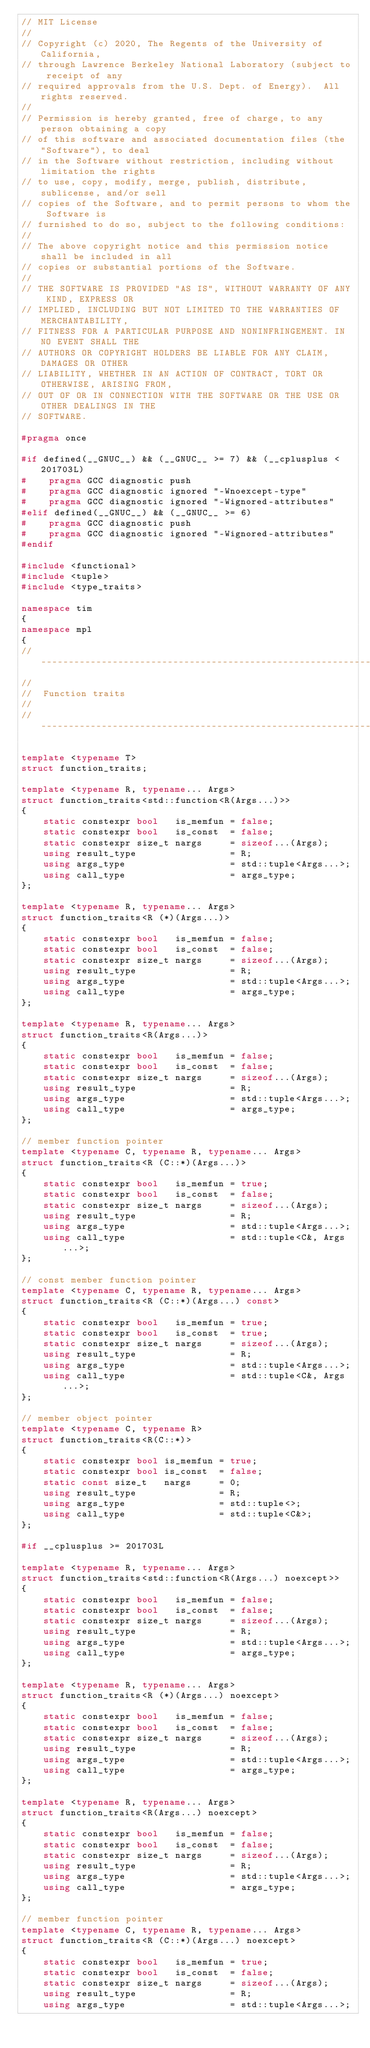<code> <loc_0><loc_0><loc_500><loc_500><_C++_>// MIT License
//
// Copyright (c) 2020, The Regents of the University of California,
// through Lawrence Berkeley National Laboratory (subject to receipt of any
// required approvals from the U.S. Dept. of Energy).  All rights reserved.
//
// Permission is hereby granted, free of charge, to any person obtaining a copy
// of this software and associated documentation files (the "Software"), to deal
// in the Software without restriction, including without limitation the rights
// to use, copy, modify, merge, publish, distribute, sublicense, and/or sell
// copies of the Software, and to permit persons to whom the Software is
// furnished to do so, subject to the following conditions:
//
// The above copyright notice and this permission notice shall be included in all
// copies or substantial portions of the Software.
//
// THE SOFTWARE IS PROVIDED "AS IS", WITHOUT WARRANTY OF ANY KIND, EXPRESS OR
// IMPLIED, INCLUDING BUT NOT LIMITED TO THE WARRANTIES OF MERCHANTABILITY,
// FITNESS FOR A PARTICULAR PURPOSE AND NONINFRINGEMENT. IN NO EVENT SHALL THE
// AUTHORS OR COPYRIGHT HOLDERS BE LIABLE FOR ANY CLAIM, DAMAGES OR OTHER
// LIABILITY, WHETHER IN AN ACTION OF CONTRACT, TORT OR OTHERWISE, ARISING FROM,
// OUT OF OR IN CONNECTION WITH THE SOFTWARE OR THE USE OR OTHER DEALINGS IN THE
// SOFTWARE.

#pragma once

#if defined(__GNUC__) && (__GNUC__ >= 7) && (__cplusplus < 201703L)
#    pragma GCC diagnostic push
#    pragma GCC diagnostic ignored "-Wnoexcept-type"
#    pragma GCC diagnostic ignored "-Wignored-attributes"
#elif defined(__GNUC__) && (__GNUC__ >= 6)
#    pragma GCC diagnostic push
#    pragma GCC diagnostic ignored "-Wignored-attributes"
#endif

#include <functional>
#include <tuple>
#include <type_traits>

namespace tim
{
namespace mpl
{
//--------------------------------------------------------------------------------------//
//
//  Function traits
//
//--------------------------------------------------------------------------------------//

template <typename T>
struct function_traits;

template <typename R, typename... Args>
struct function_traits<std::function<R(Args...)>>
{
    static constexpr bool   is_memfun = false;
    static constexpr bool   is_const  = false;
    static constexpr size_t nargs     = sizeof...(Args);
    using result_type                 = R;
    using args_type                   = std::tuple<Args...>;
    using call_type                   = args_type;
};

template <typename R, typename... Args>
struct function_traits<R (*)(Args...)>
{
    static constexpr bool   is_memfun = false;
    static constexpr bool   is_const  = false;
    static constexpr size_t nargs     = sizeof...(Args);
    using result_type                 = R;
    using args_type                   = std::tuple<Args...>;
    using call_type                   = args_type;
};

template <typename R, typename... Args>
struct function_traits<R(Args...)>
{
    static constexpr bool   is_memfun = false;
    static constexpr bool   is_const  = false;
    static constexpr size_t nargs     = sizeof...(Args);
    using result_type                 = R;
    using args_type                   = std::tuple<Args...>;
    using call_type                   = args_type;
};

// member function pointer
template <typename C, typename R, typename... Args>
struct function_traits<R (C::*)(Args...)>
{
    static constexpr bool   is_memfun = true;
    static constexpr bool   is_const  = false;
    static constexpr size_t nargs     = sizeof...(Args);
    using result_type                 = R;
    using args_type                   = std::tuple<Args...>;
    using call_type                   = std::tuple<C&, Args...>;
};

// const member function pointer
template <typename C, typename R, typename... Args>
struct function_traits<R (C::*)(Args...) const>
{
    static constexpr bool   is_memfun = true;
    static constexpr bool   is_const  = true;
    static constexpr size_t nargs     = sizeof...(Args);
    using result_type                 = R;
    using args_type                   = std::tuple<Args...>;
    using call_type                   = std::tuple<C&, Args...>;
};

// member object pointer
template <typename C, typename R>
struct function_traits<R(C::*)>
{
    static constexpr bool is_memfun = true;
    static constexpr bool is_const  = false;
    static const size_t   nargs     = 0;
    using result_type               = R;
    using args_type                 = std::tuple<>;
    using call_type                 = std::tuple<C&>;
};

#if __cplusplus >= 201703L

template <typename R, typename... Args>
struct function_traits<std::function<R(Args...) noexcept>>
{
    static constexpr bool   is_memfun = false;
    static constexpr bool   is_const  = false;
    static constexpr size_t nargs     = sizeof...(Args);
    using result_type                 = R;
    using args_type                   = std::tuple<Args...>;
    using call_type                   = args_type;
};

template <typename R, typename... Args>
struct function_traits<R (*)(Args...) noexcept>
{
    static constexpr bool   is_memfun = false;
    static constexpr bool   is_const  = false;
    static constexpr size_t nargs     = sizeof...(Args);
    using result_type                 = R;
    using args_type                   = std::tuple<Args...>;
    using call_type                   = args_type;
};

template <typename R, typename... Args>
struct function_traits<R(Args...) noexcept>
{
    static constexpr bool   is_memfun = false;
    static constexpr bool   is_const  = false;
    static constexpr size_t nargs     = sizeof...(Args);
    using result_type                 = R;
    using args_type                   = std::tuple<Args...>;
    using call_type                   = args_type;
};

// member function pointer
template <typename C, typename R, typename... Args>
struct function_traits<R (C::*)(Args...) noexcept>
{
    static constexpr bool   is_memfun = true;
    static constexpr bool   is_const  = false;
    static constexpr size_t nargs     = sizeof...(Args);
    using result_type                 = R;
    using args_type                   = std::tuple<Args...>;</code> 